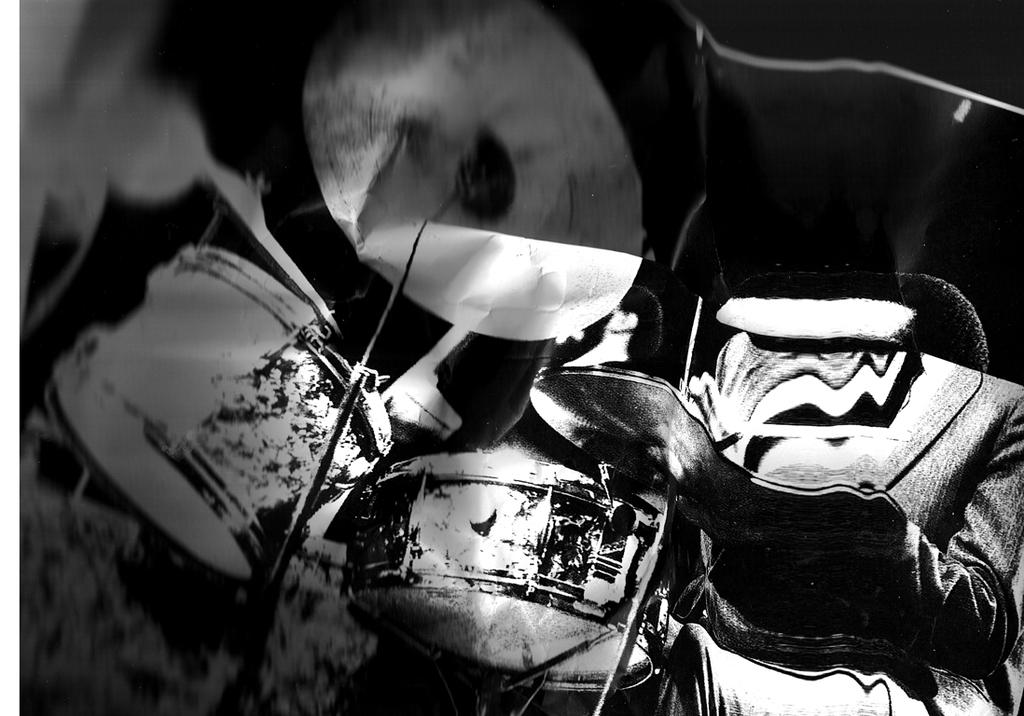What is the color scheme of the image? The picture is black and white. What objects can be seen in the image? There are bags and a drum kit in the image. Where is the drum kit located in the image? The drum kit is in the front of the image. What type of desire is being expressed by the bags in the image? There is no indication of any desires being expressed by the bags in the image, as bags are inanimate objects and do not have emotions or desires. 